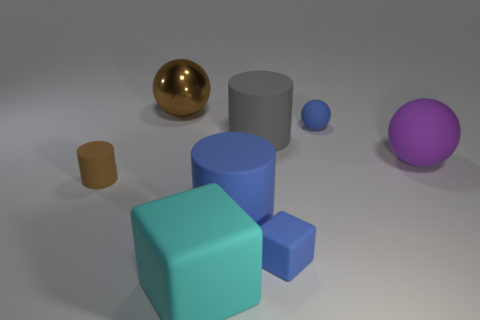Subtract all big rubber balls. How many balls are left? 2 Subtract 1 balls. How many balls are left? 2 Add 2 brown shiny balls. How many objects exist? 10 Subtract all cylinders. How many objects are left? 5 Subtract 0 brown blocks. How many objects are left? 8 Subtract all blue cylinders. Subtract all tiny cylinders. How many objects are left? 6 Add 1 large cyan rubber blocks. How many large cyan rubber blocks are left? 2 Add 4 large cyan matte cylinders. How many large cyan matte cylinders exist? 4 